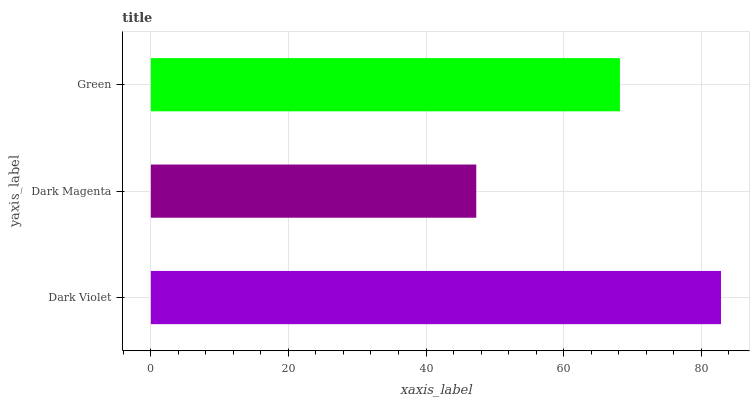Is Dark Magenta the minimum?
Answer yes or no. Yes. Is Dark Violet the maximum?
Answer yes or no. Yes. Is Green the minimum?
Answer yes or no. No. Is Green the maximum?
Answer yes or no. No. Is Green greater than Dark Magenta?
Answer yes or no. Yes. Is Dark Magenta less than Green?
Answer yes or no. Yes. Is Dark Magenta greater than Green?
Answer yes or no. No. Is Green less than Dark Magenta?
Answer yes or no. No. Is Green the high median?
Answer yes or no. Yes. Is Green the low median?
Answer yes or no. Yes. Is Dark Violet the high median?
Answer yes or no. No. Is Dark Violet the low median?
Answer yes or no. No. 